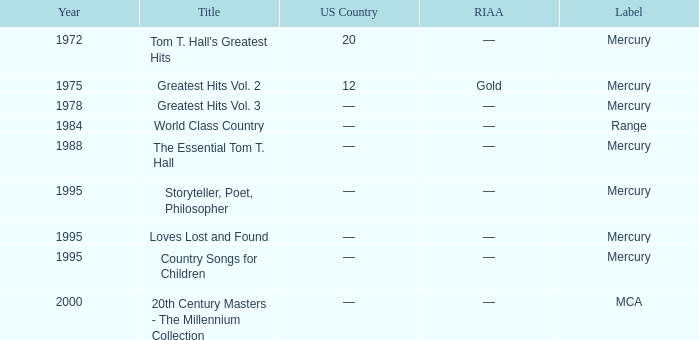When was the highest year for the title "loves lost and found"? 1995.0. 